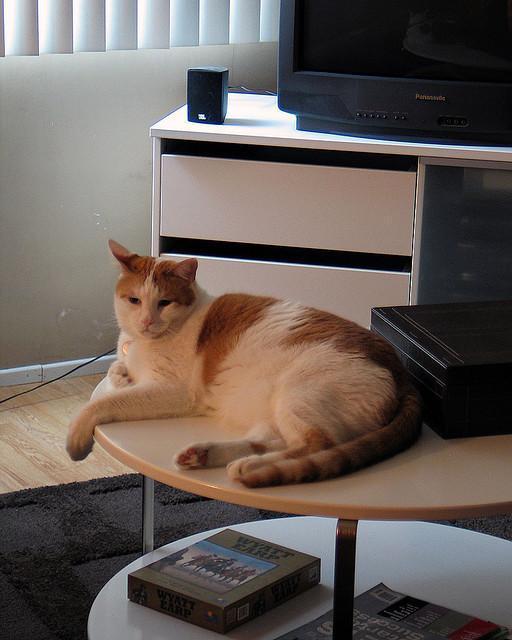How many books can be seen?
Give a very brief answer. 2. 